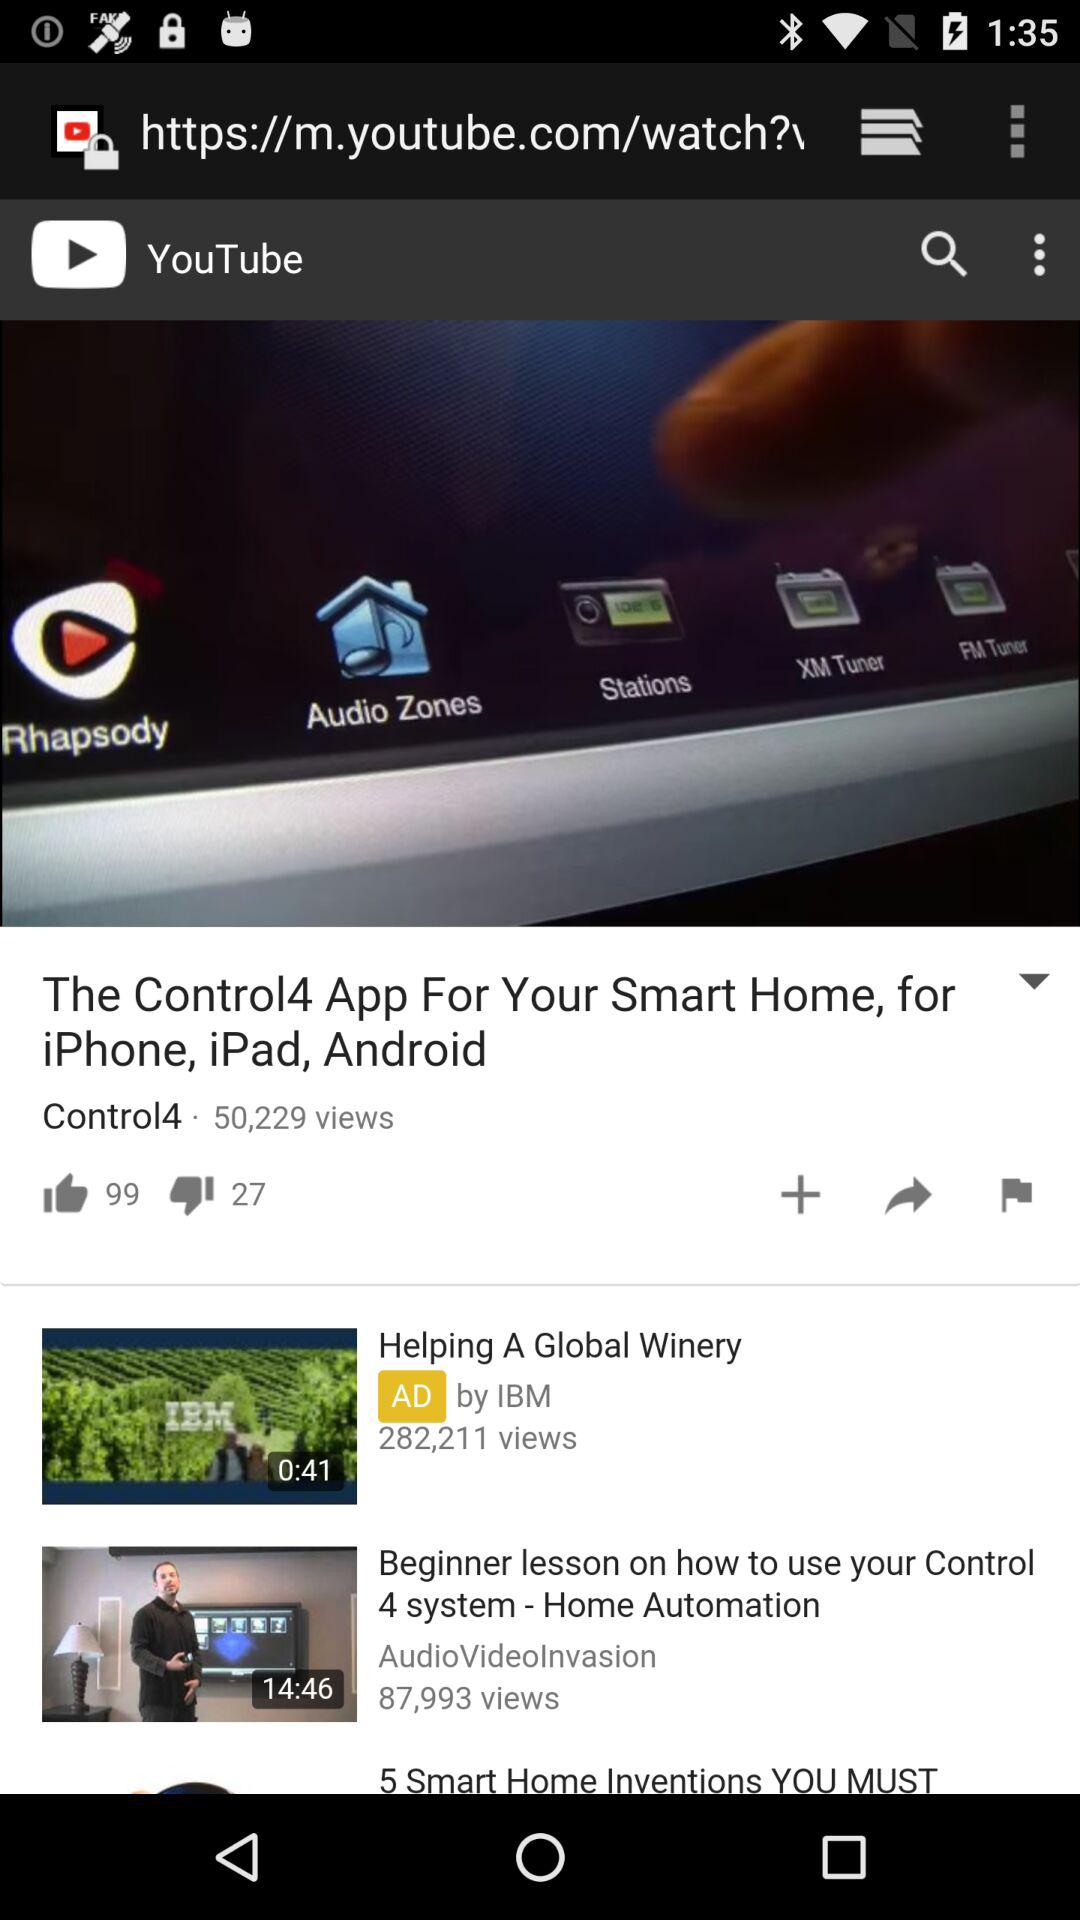What is the time duration of "how to use your Control 4 system"? The time duration of "how to use your Control 4 system" is 14 minutes 46 seconds. 